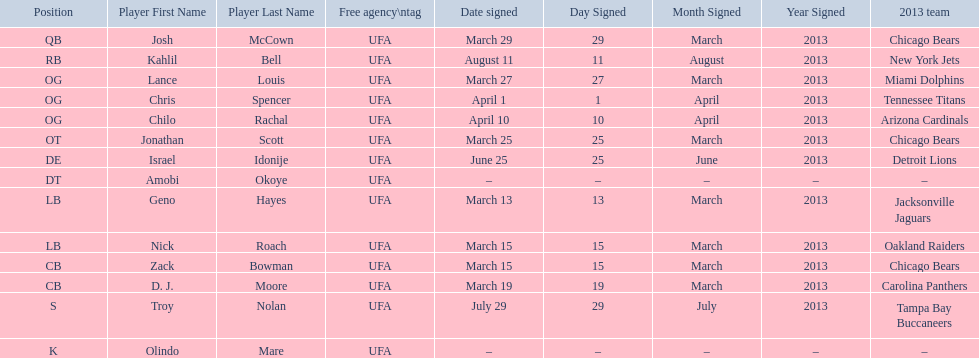What are all the dates signed? March 29, August 11, March 27, April 1, April 10, March 25, June 25, March 13, March 15, March 15, March 19, July 29. Which of these are duplicates? March 15, March 15. Who has the same one as nick roach? Zack Bowman. 